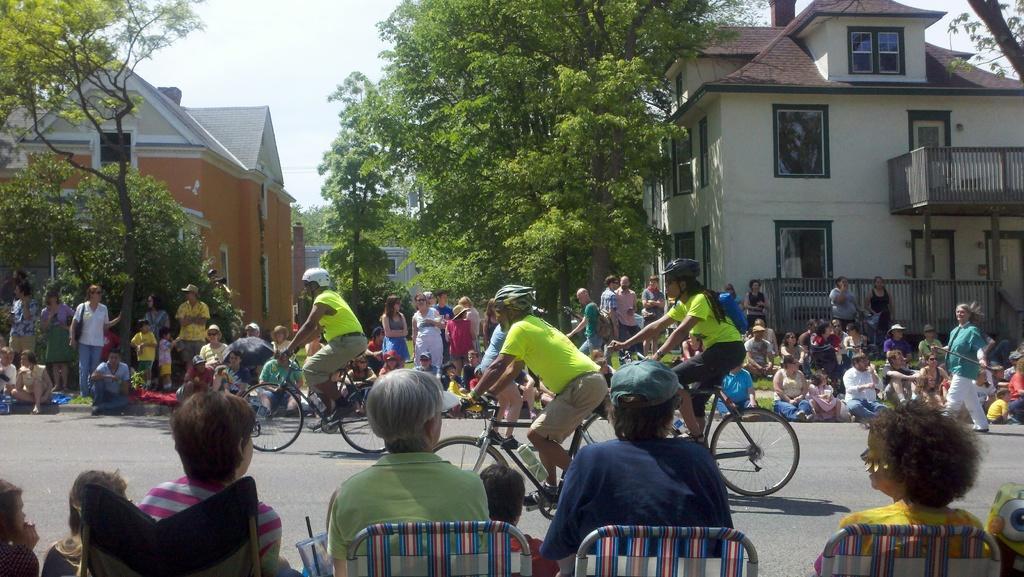Please provide a concise description of this image. Few people are riding bicycle on the road while people are watching them standing on either side of the road. 